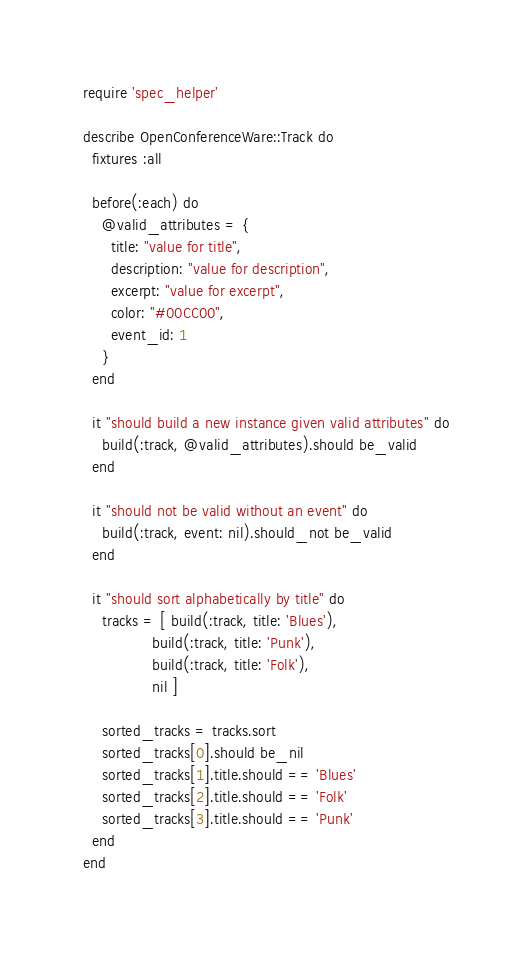Convert code to text. <code><loc_0><loc_0><loc_500><loc_500><_Ruby_>require 'spec_helper'

describe OpenConferenceWare::Track do
  fixtures :all

  before(:each) do
    @valid_attributes = {
      title: "value for title",
      description: "value for description",
      excerpt: "value for excerpt",
      color: "#00CC00",
      event_id: 1
    }
  end

  it "should build a new instance given valid attributes" do
    build(:track, @valid_attributes).should be_valid
  end

  it "should not be valid without an event" do
    build(:track, event: nil).should_not be_valid
  end

  it "should sort alphabetically by title" do
    tracks = [ build(:track, title: 'Blues'),
               build(:track, title: 'Punk'),
               build(:track, title: 'Folk'),
               nil ]

    sorted_tracks = tracks.sort
    sorted_tracks[0].should be_nil
    sorted_tracks[1].title.should == 'Blues'
    sorted_tracks[2].title.should == 'Folk'
    sorted_tracks[3].title.should == 'Punk'
  end
end
</code> 